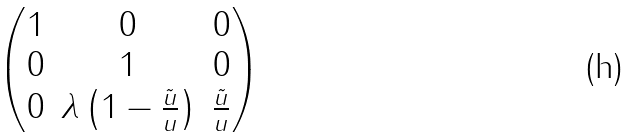Convert formula to latex. <formula><loc_0><loc_0><loc_500><loc_500>\begin{pmatrix} 1 & 0 & 0 \\ 0 & 1 & 0 \\ 0 & \lambda \left ( 1 - \frac { \tilde { u } } { u } \right ) & \frac { \tilde { u } } { u } \\ \end{pmatrix}</formula> 